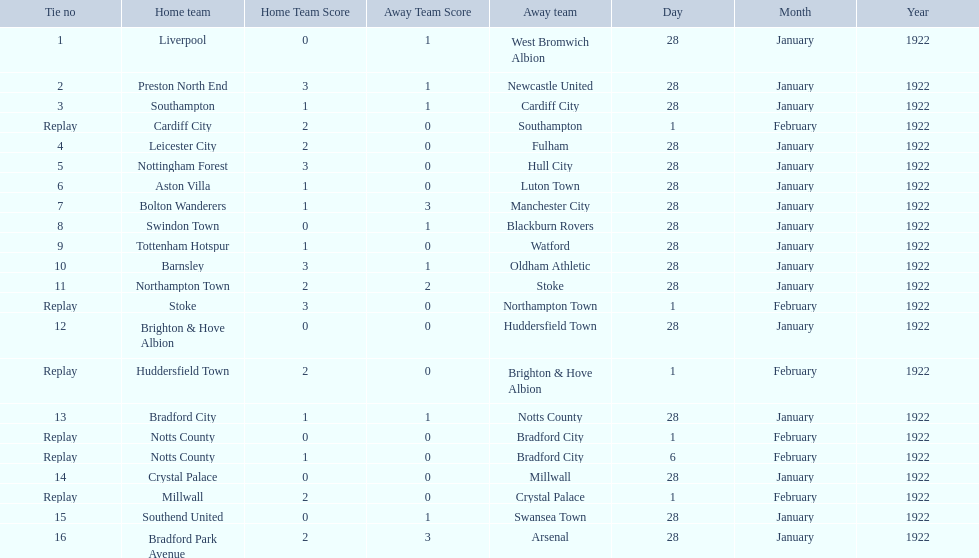Which team had a score of 0-1? Liverpool. Which team had a replay? Cardiff City. Which team had the same score as aston villa? Tottenham Hotspur. 